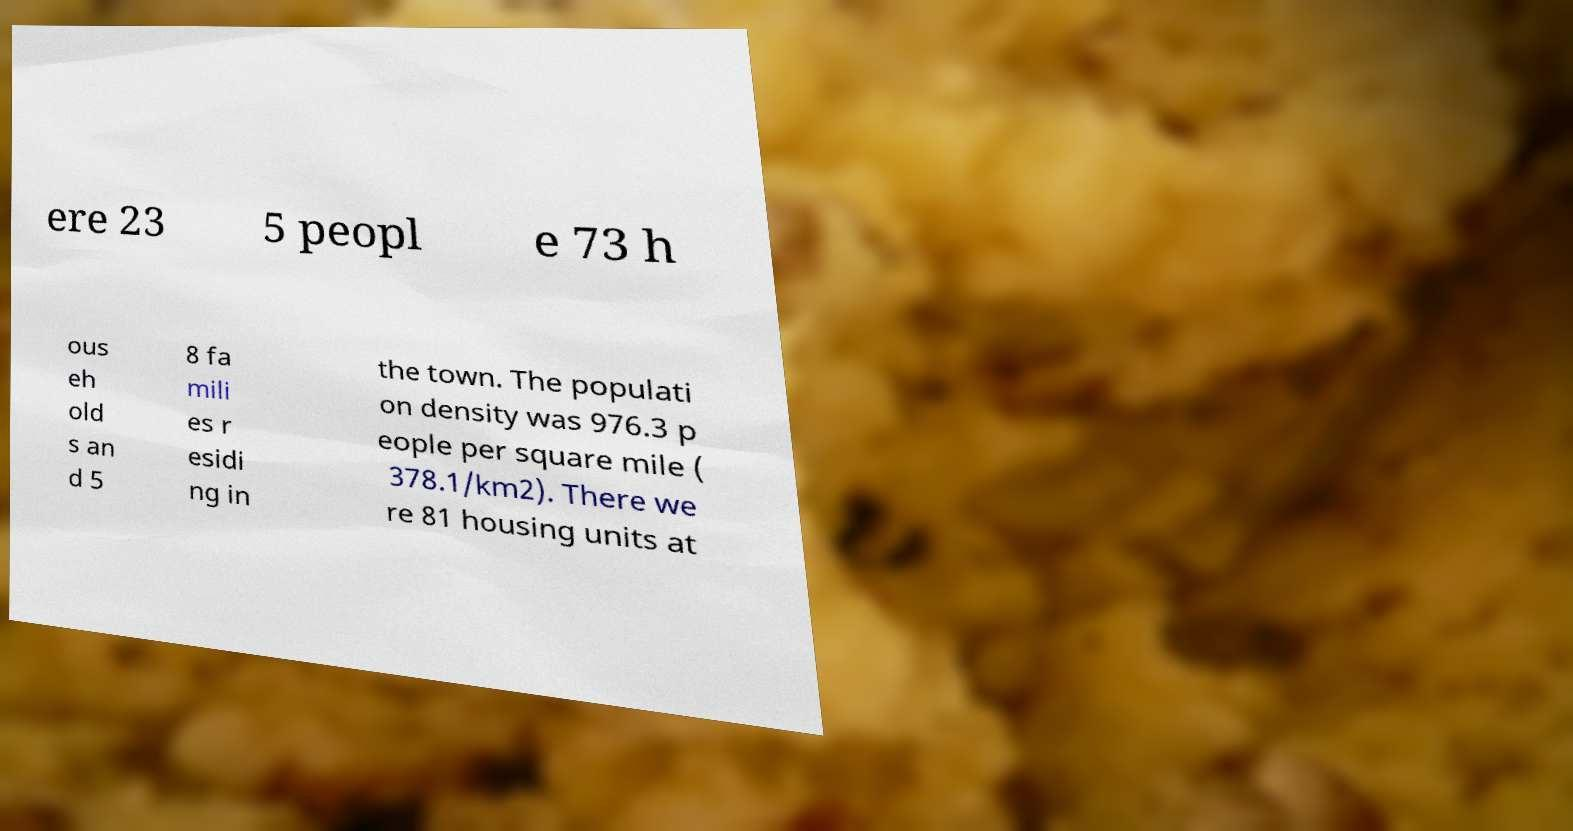For documentation purposes, I need the text within this image transcribed. Could you provide that? ere 23 5 peopl e 73 h ous eh old s an d 5 8 fa mili es r esidi ng in the town. The populati on density was 976.3 p eople per square mile ( 378.1/km2). There we re 81 housing units at 